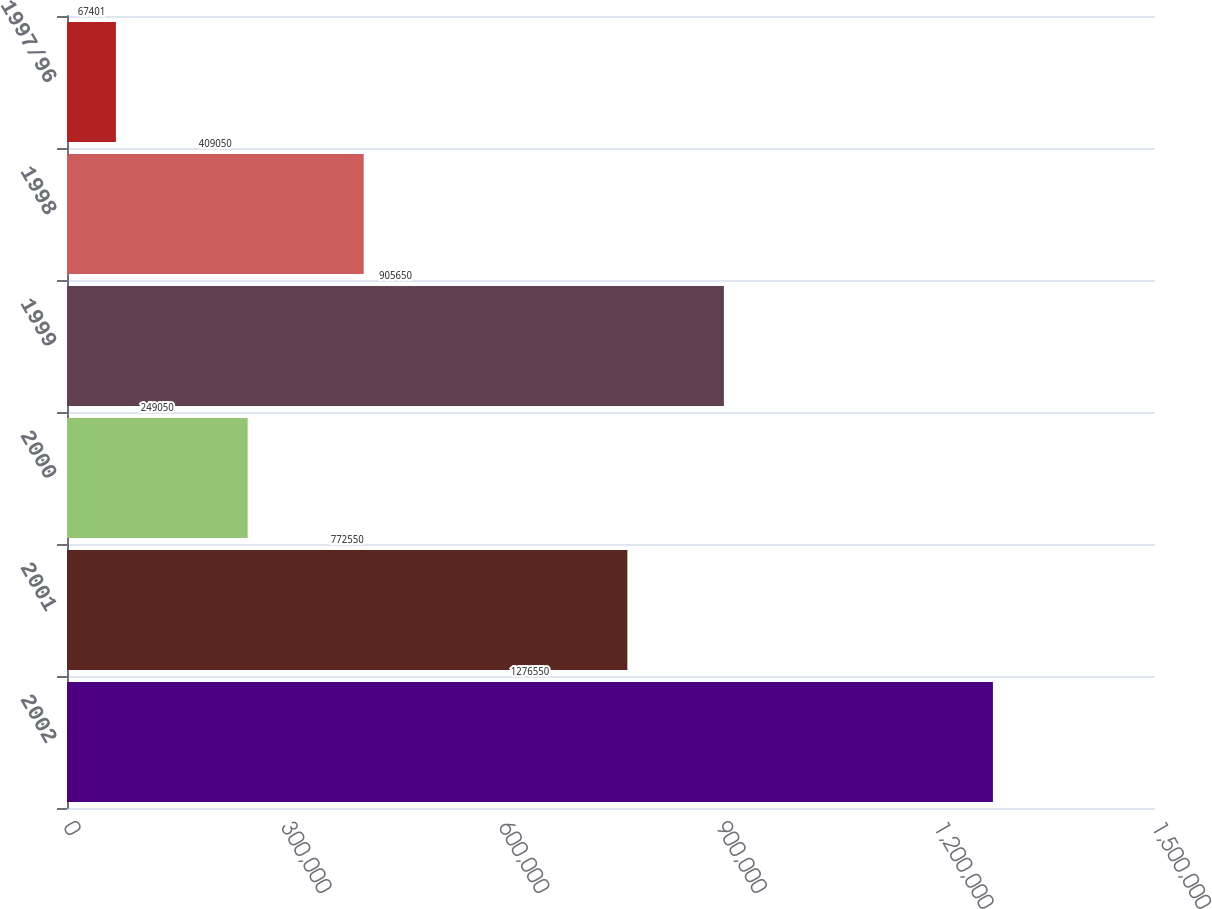Convert chart to OTSL. <chart><loc_0><loc_0><loc_500><loc_500><bar_chart><fcel>2002<fcel>2001<fcel>2000<fcel>1999<fcel>1998<fcel>1997/96<nl><fcel>1.27655e+06<fcel>772550<fcel>249050<fcel>905650<fcel>409050<fcel>67401<nl></chart> 